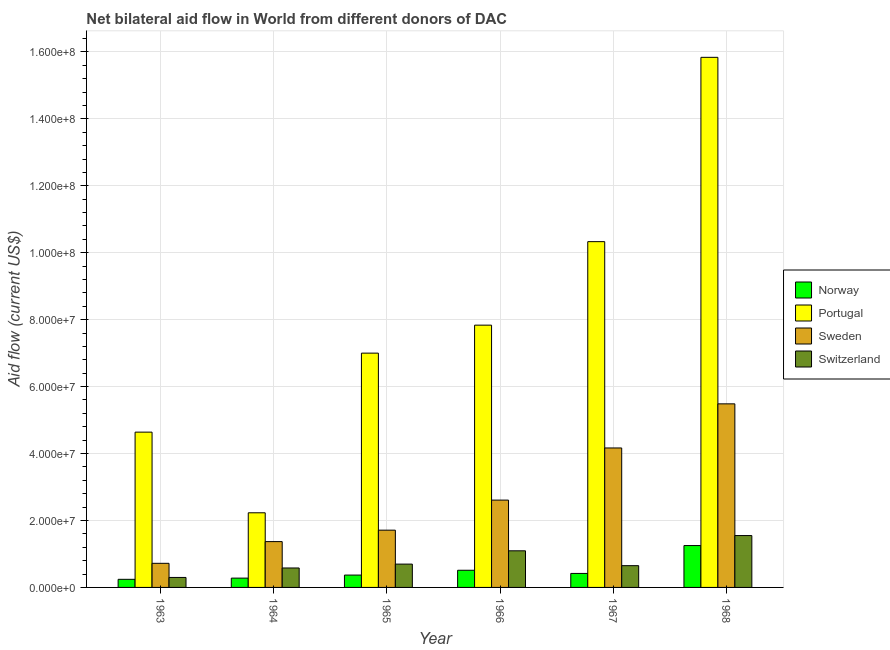How many groups of bars are there?
Your answer should be compact. 6. Are the number of bars per tick equal to the number of legend labels?
Offer a very short reply. Yes. Are the number of bars on each tick of the X-axis equal?
Ensure brevity in your answer.  Yes. How many bars are there on the 6th tick from the right?
Offer a terse response. 4. What is the label of the 6th group of bars from the left?
Make the answer very short. 1968. What is the amount of aid given by norway in 1964?
Make the answer very short. 2.78e+06. Across all years, what is the maximum amount of aid given by sweden?
Provide a short and direct response. 5.48e+07. Across all years, what is the minimum amount of aid given by portugal?
Make the answer very short. 2.23e+07. In which year was the amount of aid given by switzerland maximum?
Ensure brevity in your answer.  1968. In which year was the amount of aid given by sweden minimum?
Make the answer very short. 1963. What is the total amount of aid given by norway in the graph?
Your answer should be very brief. 3.07e+07. What is the difference between the amount of aid given by portugal in 1963 and that in 1966?
Your answer should be very brief. -3.20e+07. What is the difference between the amount of aid given by sweden in 1963 and the amount of aid given by portugal in 1966?
Your answer should be compact. -1.89e+07. What is the average amount of aid given by norway per year?
Your response must be concise. 5.12e+06. In how many years, is the amount of aid given by norway greater than 60000000 US$?
Your response must be concise. 0. What is the ratio of the amount of aid given by sweden in 1965 to that in 1968?
Give a very brief answer. 0.31. Is the amount of aid given by switzerland in 1963 less than that in 1968?
Your answer should be very brief. Yes. What is the difference between the highest and the second highest amount of aid given by switzerland?
Your answer should be very brief. 4.56e+06. What is the difference between the highest and the lowest amount of aid given by switzerland?
Offer a very short reply. 1.25e+07. In how many years, is the amount of aid given by sweden greater than the average amount of aid given by sweden taken over all years?
Your response must be concise. 2. Is the sum of the amount of aid given by portugal in 1965 and 1966 greater than the maximum amount of aid given by norway across all years?
Offer a terse response. No. What does the 4th bar from the right in 1966 represents?
Provide a short and direct response. Norway. Is it the case that in every year, the sum of the amount of aid given by norway and amount of aid given by portugal is greater than the amount of aid given by sweden?
Keep it short and to the point. Yes. How many years are there in the graph?
Provide a short and direct response. 6. What is the difference between two consecutive major ticks on the Y-axis?
Provide a short and direct response. 2.00e+07. Are the values on the major ticks of Y-axis written in scientific E-notation?
Offer a very short reply. Yes. Does the graph contain any zero values?
Offer a terse response. No. How many legend labels are there?
Offer a terse response. 4. How are the legend labels stacked?
Your answer should be very brief. Vertical. What is the title of the graph?
Provide a short and direct response. Net bilateral aid flow in World from different donors of DAC. What is the label or title of the Y-axis?
Make the answer very short. Aid flow (current US$). What is the Aid flow (current US$) of Norway in 1963?
Your answer should be compact. 2.42e+06. What is the Aid flow (current US$) of Portugal in 1963?
Your response must be concise. 4.64e+07. What is the Aid flow (current US$) in Sweden in 1963?
Give a very brief answer. 7.20e+06. What is the Aid flow (current US$) in Switzerland in 1963?
Your answer should be very brief. 2.98e+06. What is the Aid flow (current US$) of Norway in 1964?
Provide a short and direct response. 2.78e+06. What is the Aid flow (current US$) in Portugal in 1964?
Provide a short and direct response. 2.23e+07. What is the Aid flow (current US$) of Sweden in 1964?
Offer a very short reply. 1.37e+07. What is the Aid flow (current US$) in Switzerland in 1964?
Provide a short and direct response. 5.81e+06. What is the Aid flow (current US$) of Norway in 1965?
Give a very brief answer. 3.69e+06. What is the Aid flow (current US$) in Portugal in 1965?
Your answer should be very brief. 7.00e+07. What is the Aid flow (current US$) in Sweden in 1965?
Your response must be concise. 1.71e+07. What is the Aid flow (current US$) in Switzerland in 1965?
Offer a very short reply. 6.97e+06. What is the Aid flow (current US$) in Norway in 1966?
Offer a very short reply. 5.13e+06. What is the Aid flow (current US$) of Portugal in 1966?
Make the answer very short. 7.84e+07. What is the Aid flow (current US$) of Sweden in 1966?
Offer a very short reply. 2.61e+07. What is the Aid flow (current US$) in Switzerland in 1966?
Provide a succinct answer. 1.09e+07. What is the Aid flow (current US$) of Norway in 1967?
Provide a succinct answer. 4.18e+06. What is the Aid flow (current US$) in Portugal in 1967?
Make the answer very short. 1.03e+08. What is the Aid flow (current US$) of Sweden in 1967?
Offer a very short reply. 4.17e+07. What is the Aid flow (current US$) of Switzerland in 1967?
Ensure brevity in your answer.  6.50e+06. What is the Aid flow (current US$) of Norway in 1968?
Your response must be concise. 1.25e+07. What is the Aid flow (current US$) of Portugal in 1968?
Your response must be concise. 1.58e+08. What is the Aid flow (current US$) of Sweden in 1968?
Give a very brief answer. 5.48e+07. What is the Aid flow (current US$) of Switzerland in 1968?
Offer a terse response. 1.55e+07. Across all years, what is the maximum Aid flow (current US$) in Norway?
Make the answer very short. 1.25e+07. Across all years, what is the maximum Aid flow (current US$) in Portugal?
Give a very brief answer. 1.58e+08. Across all years, what is the maximum Aid flow (current US$) of Sweden?
Offer a terse response. 5.48e+07. Across all years, what is the maximum Aid flow (current US$) in Switzerland?
Provide a succinct answer. 1.55e+07. Across all years, what is the minimum Aid flow (current US$) of Norway?
Make the answer very short. 2.42e+06. Across all years, what is the minimum Aid flow (current US$) of Portugal?
Provide a succinct answer. 2.23e+07. Across all years, what is the minimum Aid flow (current US$) in Sweden?
Provide a succinct answer. 7.20e+06. Across all years, what is the minimum Aid flow (current US$) in Switzerland?
Your answer should be very brief. 2.98e+06. What is the total Aid flow (current US$) in Norway in the graph?
Ensure brevity in your answer.  3.07e+07. What is the total Aid flow (current US$) of Portugal in the graph?
Give a very brief answer. 4.79e+08. What is the total Aid flow (current US$) in Sweden in the graph?
Provide a short and direct response. 1.61e+08. What is the total Aid flow (current US$) in Switzerland in the graph?
Give a very brief answer. 4.87e+07. What is the difference between the Aid flow (current US$) of Norway in 1963 and that in 1964?
Offer a very short reply. -3.60e+05. What is the difference between the Aid flow (current US$) of Portugal in 1963 and that in 1964?
Provide a succinct answer. 2.41e+07. What is the difference between the Aid flow (current US$) in Sweden in 1963 and that in 1964?
Ensure brevity in your answer.  -6.49e+06. What is the difference between the Aid flow (current US$) of Switzerland in 1963 and that in 1964?
Provide a short and direct response. -2.83e+06. What is the difference between the Aid flow (current US$) in Norway in 1963 and that in 1965?
Your answer should be very brief. -1.27e+06. What is the difference between the Aid flow (current US$) in Portugal in 1963 and that in 1965?
Provide a succinct answer. -2.36e+07. What is the difference between the Aid flow (current US$) of Sweden in 1963 and that in 1965?
Offer a terse response. -9.91e+06. What is the difference between the Aid flow (current US$) of Switzerland in 1963 and that in 1965?
Your answer should be very brief. -3.99e+06. What is the difference between the Aid flow (current US$) in Norway in 1963 and that in 1966?
Provide a succinct answer. -2.71e+06. What is the difference between the Aid flow (current US$) of Portugal in 1963 and that in 1966?
Provide a succinct answer. -3.20e+07. What is the difference between the Aid flow (current US$) of Sweden in 1963 and that in 1966?
Provide a short and direct response. -1.89e+07. What is the difference between the Aid flow (current US$) in Switzerland in 1963 and that in 1966?
Offer a terse response. -7.96e+06. What is the difference between the Aid flow (current US$) of Norway in 1963 and that in 1967?
Provide a succinct answer. -1.76e+06. What is the difference between the Aid flow (current US$) in Portugal in 1963 and that in 1967?
Offer a very short reply. -5.69e+07. What is the difference between the Aid flow (current US$) of Sweden in 1963 and that in 1967?
Give a very brief answer. -3.45e+07. What is the difference between the Aid flow (current US$) of Switzerland in 1963 and that in 1967?
Your response must be concise. -3.52e+06. What is the difference between the Aid flow (current US$) in Norway in 1963 and that in 1968?
Ensure brevity in your answer.  -1.01e+07. What is the difference between the Aid flow (current US$) in Portugal in 1963 and that in 1968?
Offer a very short reply. -1.12e+08. What is the difference between the Aid flow (current US$) of Sweden in 1963 and that in 1968?
Offer a very short reply. -4.76e+07. What is the difference between the Aid flow (current US$) in Switzerland in 1963 and that in 1968?
Your response must be concise. -1.25e+07. What is the difference between the Aid flow (current US$) of Norway in 1964 and that in 1965?
Provide a succinct answer. -9.10e+05. What is the difference between the Aid flow (current US$) in Portugal in 1964 and that in 1965?
Provide a succinct answer. -4.77e+07. What is the difference between the Aid flow (current US$) of Sweden in 1964 and that in 1965?
Provide a short and direct response. -3.42e+06. What is the difference between the Aid flow (current US$) in Switzerland in 1964 and that in 1965?
Provide a succinct answer. -1.16e+06. What is the difference between the Aid flow (current US$) of Norway in 1964 and that in 1966?
Your answer should be very brief. -2.35e+06. What is the difference between the Aid flow (current US$) in Portugal in 1964 and that in 1966?
Your answer should be very brief. -5.61e+07. What is the difference between the Aid flow (current US$) in Sweden in 1964 and that in 1966?
Offer a terse response. -1.24e+07. What is the difference between the Aid flow (current US$) of Switzerland in 1964 and that in 1966?
Give a very brief answer. -5.13e+06. What is the difference between the Aid flow (current US$) of Norway in 1964 and that in 1967?
Ensure brevity in your answer.  -1.40e+06. What is the difference between the Aid flow (current US$) in Portugal in 1964 and that in 1967?
Ensure brevity in your answer.  -8.10e+07. What is the difference between the Aid flow (current US$) of Sweden in 1964 and that in 1967?
Your answer should be compact. -2.80e+07. What is the difference between the Aid flow (current US$) in Switzerland in 1964 and that in 1967?
Your answer should be compact. -6.90e+05. What is the difference between the Aid flow (current US$) in Norway in 1964 and that in 1968?
Ensure brevity in your answer.  -9.73e+06. What is the difference between the Aid flow (current US$) in Portugal in 1964 and that in 1968?
Provide a short and direct response. -1.36e+08. What is the difference between the Aid flow (current US$) in Sweden in 1964 and that in 1968?
Your response must be concise. -4.12e+07. What is the difference between the Aid flow (current US$) of Switzerland in 1964 and that in 1968?
Ensure brevity in your answer.  -9.69e+06. What is the difference between the Aid flow (current US$) of Norway in 1965 and that in 1966?
Offer a terse response. -1.44e+06. What is the difference between the Aid flow (current US$) of Portugal in 1965 and that in 1966?
Give a very brief answer. -8.36e+06. What is the difference between the Aid flow (current US$) in Sweden in 1965 and that in 1966?
Provide a short and direct response. -8.98e+06. What is the difference between the Aid flow (current US$) of Switzerland in 1965 and that in 1966?
Give a very brief answer. -3.97e+06. What is the difference between the Aid flow (current US$) of Norway in 1965 and that in 1967?
Make the answer very short. -4.90e+05. What is the difference between the Aid flow (current US$) in Portugal in 1965 and that in 1967?
Offer a terse response. -3.33e+07. What is the difference between the Aid flow (current US$) of Sweden in 1965 and that in 1967?
Keep it short and to the point. -2.46e+07. What is the difference between the Aid flow (current US$) of Switzerland in 1965 and that in 1967?
Your answer should be compact. 4.70e+05. What is the difference between the Aid flow (current US$) of Norway in 1965 and that in 1968?
Offer a very short reply. -8.82e+06. What is the difference between the Aid flow (current US$) of Portugal in 1965 and that in 1968?
Offer a terse response. -8.84e+07. What is the difference between the Aid flow (current US$) in Sweden in 1965 and that in 1968?
Keep it short and to the point. -3.77e+07. What is the difference between the Aid flow (current US$) in Switzerland in 1965 and that in 1968?
Make the answer very short. -8.53e+06. What is the difference between the Aid flow (current US$) of Norway in 1966 and that in 1967?
Keep it short and to the point. 9.50e+05. What is the difference between the Aid flow (current US$) in Portugal in 1966 and that in 1967?
Your answer should be compact. -2.50e+07. What is the difference between the Aid flow (current US$) of Sweden in 1966 and that in 1967?
Your answer should be compact. -1.56e+07. What is the difference between the Aid flow (current US$) of Switzerland in 1966 and that in 1967?
Your answer should be compact. 4.44e+06. What is the difference between the Aid flow (current US$) of Norway in 1966 and that in 1968?
Offer a terse response. -7.38e+06. What is the difference between the Aid flow (current US$) in Portugal in 1966 and that in 1968?
Your response must be concise. -8.00e+07. What is the difference between the Aid flow (current US$) in Sweden in 1966 and that in 1968?
Offer a very short reply. -2.88e+07. What is the difference between the Aid flow (current US$) of Switzerland in 1966 and that in 1968?
Your answer should be compact. -4.56e+06. What is the difference between the Aid flow (current US$) of Norway in 1967 and that in 1968?
Your answer should be very brief. -8.33e+06. What is the difference between the Aid flow (current US$) in Portugal in 1967 and that in 1968?
Offer a very short reply. -5.51e+07. What is the difference between the Aid flow (current US$) of Sweden in 1967 and that in 1968?
Give a very brief answer. -1.32e+07. What is the difference between the Aid flow (current US$) in Switzerland in 1967 and that in 1968?
Your response must be concise. -9.00e+06. What is the difference between the Aid flow (current US$) of Norway in 1963 and the Aid flow (current US$) of Portugal in 1964?
Provide a short and direct response. -1.99e+07. What is the difference between the Aid flow (current US$) in Norway in 1963 and the Aid flow (current US$) in Sweden in 1964?
Provide a succinct answer. -1.13e+07. What is the difference between the Aid flow (current US$) of Norway in 1963 and the Aid flow (current US$) of Switzerland in 1964?
Your answer should be compact. -3.39e+06. What is the difference between the Aid flow (current US$) in Portugal in 1963 and the Aid flow (current US$) in Sweden in 1964?
Offer a terse response. 3.27e+07. What is the difference between the Aid flow (current US$) of Portugal in 1963 and the Aid flow (current US$) of Switzerland in 1964?
Your answer should be very brief. 4.06e+07. What is the difference between the Aid flow (current US$) in Sweden in 1963 and the Aid flow (current US$) in Switzerland in 1964?
Keep it short and to the point. 1.39e+06. What is the difference between the Aid flow (current US$) in Norway in 1963 and the Aid flow (current US$) in Portugal in 1965?
Ensure brevity in your answer.  -6.76e+07. What is the difference between the Aid flow (current US$) of Norway in 1963 and the Aid flow (current US$) of Sweden in 1965?
Your response must be concise. -1.47e+07. What is the difference between the Aid flow (current US$) in Norway in 1963 and the Aid flow (current US$) in Switzerland in 1965?
Provide a succinct answer. -4.55e+06. What is the difference between the Aid flow (current US$) of Portugal in 1963 and the Aid flow (current US$) of Sweden in 1965?
Offer a terse response. 2.93e+07. What is the difference between the Aid flow (current US$) in Portugal in 1963 and the Aid flow (current US$) in Switzerland in 1965?
Your response must be concise. 3.94e+07. What is the difference between the Aid flow (current US$) of Sweden in 1963 and the Aid flow (current US$) of Switzerland in 1965?
Ensure brevity in your answer.  2.30e+05. What is the difference between the Aid flow (current US$) of Norway in 1963 and the Aid flow (current US$) of Portugal in 1966?
Give a very brief answer. -7.59e+07. What is the difference between the Aid flow (current US$) in Norway in 1963 and the Aid flow (current US$) in Sweden in 1966?
Keep it short and to the point. -2.37e+07. What is the difference between the Aid flow (current US$) in Norway in 1963 and the Aid flow (current US$) in Switzerland in 1966?
Keep it short and to the point. -8.52e+06. What is the difference between the Aid flow (current US$) of Portugal in 1963 and the Aid flow (current US$) of Sweden in 1966?
Your answer should be very brief. 2.03e+07. What is the difference between the Aid flow (current US$) of Portugal in 1963 and the Aid flow (current US$) of Switzerland in 1966?
Your response must be concise. 3.55e+07. What is the difference between the Aid flow (current US$) in Sweden in 1963 and the Aid flow (current US$) in Switzerland in 1966?
Make the answer very short. -3.74e+06. What is the difference between the Aid flow (current US$) of Norway in 1963 and the Aid flow (current US$) of Portugal in 1967?
Provide a short and direct response. -1.01e+08. What is the difference between the Aid flow (current US$) in Norway in 1963 and the Aid flow (current US$) in Sweden in 1967?
Offer a terse response. -3.92e+07. What is the difference between the Aid flow (current US$) in Norway in 1963 and the Aid flow (current US$) in Switzerland in 1967?
Keep it short and to the point. -4.08e+06. What is the difference between the Aid flow (current US$) of Portugal in 1963 and the Aid flow (current US$) of Sweden in 1967?
Provide a succinct answer. 4.73e+06. What is the difference between the Aid flow (current US$) in Portugal in 1963 and the Aid flow (current US$) in Switzerland in 1967?
Offer a terse response. 3.99e+07. What is the difference between the Aid flow (current US$) in Sweden in 1963 and the Aid flow (current US$) in Switzerland in 1967?
Your answer should be compact. 7.00e+05. What is the difference between the Aid flow (current US$) of Norway in 1963 and the Aid flow (current US$) of Portugal in 1968?
Keep it short and to the point. -1.56e+08. What is the difference between the Aid flow (current US$) in Norway in 1963 and the Aid flow (current US$) in Sweden in 1968?
Offer a very short reply. -5.24e+07. What is the difference between the Aid flow (current US$) of Norway in 1963 and the Aid flow (current US$) of Switzerland in 1968?
Provide a succinct answer. -1.31e+07. What is the difference between the Aid flow (current US$) of Portugal in 1963 and the Aid flow (current US$) of Sweden in 1968?
Provide a short and direct response. -8.45e+06. What is the difference between the Aid flow (current US$) of Portugal in 1963 and the Aid flow (current US$) of Switzerland in 1968?
Offer a terse response. 3.09e+07. What is the difference between the Aid flow (current US$) in Sweden in 1963 and the Aid flow (current US$) in Switzerland in 1968?
Ensure brevity in your answer.  -8.30e+06. What is the difference between the Aid flow (current US$) in Norway in 1964 and the Aid flow (current US$) in Portugal in 1965?
Keep it short and to the point. -6.72e+07. What is the difference between the Aid flow (current US$) of Norway in 1964 and the Aid flow (current US$) of Sweden in 1965?
Keep it short and to the point. -1.43e+07. What is the difference between the Aid flow (current US$) in Norway in 1964 and the Aid flow (current US$) in Switzerland in 1965?
Offer a terse response. -4.19e+06. What is the difference between the Aid flow (current US$) of Portugal in 1964 and the Aid flow (current US$) of Sweden in 1965?
Make the answer very short. 5.19e+06. What is the difference between the Aid flow (current US$) of Portugal in 1964 and the Aid flow (current US$) of Switzerland in 1965?
Make the answer very short. 1.53e+07. What is the difference between the Aid flow (current US$) in Sweden in 1964 and the Aid flow (current US$) in Switzerland in 1965?
Your answer should be very brief. 6.72e+06. What is the difference between the Aid flow (current US$) of Norway in 1964 and the Aid flow (current US$) of Portugal in 1966?
Offer a terse response. -7.56e+07. What is the difference between the Aid flow (current US$) in Norway in 1964 and the Aid flow (current US$) in Sweden in 1966?
Offer a terse response. -2.33e+07. What is the difference between the Aid flow (current US$) of Norway in 1964 and the Aid flow (current US$) of Switzerland in 1966?
Offer a terse response. -8.16e+06. What is the difference between the Aid flow (current US$) in Portugal in 1964 and the Aid flow (current US$) in Sweden in 1966?
Offer a very short reply. -3.79e+06. What is the difference between the Aid flow (current US$) in Portugal in 1964 and the Aid flow (current US$) in Switzerland in 1966?
Offer a terse response. 1.14e+07. What is the difference between the Aid flow (current US$) in Sweden in 1964 and the Aid flow (current US$) in Switzerland in 1966?
Offer a very short reply. 2.75e+06. What is the difference between the Aid flow (current US$) in Norway in 1964 and the Aid flow (current US$) in Portugal in 1967?
Provide a short and direct response. -1.01e+08. What is the difference between the Aid flow (current US$) of Norway in 1964 and the Aid flow (current US$) of Sweden in 1967?
Your answer should be compact. -3.89e+07. What is the difference between the Aid flow (current US$) of Norway in 1964 and the Aid flow (current US$) of Switzerland in 1967?
Keep it short and to the point. -3.72e+06. What is the difference between the Aid flow (current US$) in Portugal in 1964 and the Aid flow (current US$) in Sweden in 1967?
Your answer should be compact. -1.94e+07. What is the difference between the Aid flow (current US$) of Portugal in 1964 and the Aid flow (current US$) of Switzerland in 1967?
Make the answer very short. 1.58e+07. What is the difference between the Aid flow (current US$) in Sweden in 1964 and the Aid flow (current US$) in Switzerland in 1967?
Your answer should be very brief. 7.19e+06. What is the difference between the Aid flow (current US$) of Norway in 1964 and the Aid flow (current US$) of Portugal in 1968?
Provide a succinct answer. -1.56e+08. What is the difference between the Aid flow (current US$) in Norway in 1964 and the Aid flow (current US$) in Sweden in 1968?
Offer a very short reply. -5.21e+07. What is the difference between the Aid flow (current US$) of Norway in 1964 and the Aid flow (current US$) of Switzerland in 1968?
Provide a short and direct response. -1.27e+07. What is the difference between the Aid flow (current US$) of Portugal in 1964 and the Aid flow (current US$) of Sweden in 1968?
Offer a terse response. -3.26e+07. What is the difference between the Aid flow (current US$) in Portugal in 1964 and the Aid flow (current US$) in Switzerland in 1968?
Your answer should be compact. 6.80e+06. What is the difference between the Aid flow (current US$) in Sweden in 1964 and the Aid flow (current US$) in Switzerland in 1968?
Make the answer very short. -1.81e+06. What is the difference between the Aid flow (current US$) in Norway in 1965 and the Aid flow (current US$) in Portugal in 1966?
Your answer should be compact. -7.47e+07. What is the difference between the Aid flow (current US$) in Norway in 1965 and the Aid flow (current US$) in Sweden in 1966?
Provide a succinct answer. -2.24e+07. What is the difference between the Aid flow (current US$) of Norway in 1965 and the Aid flow (current US$) of Switzerland in 1966?
Ensure brevity in your answer.  -7.25e+06. What is the difference between the Aid flow (current US$) in Portugal in 1965 and the Aid flow (current US$) in Sweden in 1966?
Your response must be concise. 4.39e+07. What is the difference between the Aid flow (current US$) of Portugal in 1965 and the Aid flow (current US$) of Switzerland in 1966?
Provide a succinct answer. 5.91e+07. What is the difference between the Aid flow (current US$) in Sweden in 1965 and the Aid flow (current US$) in Switzerland in 1966?
Keep it short and to the point. 6.17e+06. What is the difference between the Aid flow (current US$) in Norway in 1965 and the Aid flow (current US$) in Portugal in 1967?
Your answer should be compact. -9.96e+07. What is the difference between the Aid flow (current US$) of Norway in 1965 and the Aid flow (current US$) of Sweden in 1967?
Keep it short and to the point. -3.80e+07. What is the difference between the Aid flow (current US$) of Norway in 1965 and the Aid flow (current US$) of Switzerland in 1967?
Keep it short and to the point. -2.81e+06. What is the difference between the Aid flow (current US$) in Portugal in 1965 and the Aid flow (current US$) in Sweden in 1967?
Make the answer very short. 2.83e+07. What is the difference between the Aid flow (current US$) of Portugal in 1965 and the Aid flow (current US$) of Switzerland in 1967?
Offer a very short reply. 6.35e+07. What is the difference between the Aid flow (current US$) in Sweden in 1965 and the Aid flow (current US$) in Switzerland in 1967?
Provide a short and direct response. 1.06e+07. What is the difference between the Aid flow (current US$) in Norway in 1965 and the Aid flow (current US$) in Portugal in 1968?
Your answer should be very brief. -1.55e+08. What is the difference between the Aid flow (current US$) in Norway in 1965 and the Aid flow (current US$) in Sweden in 1968?
Ensure brevity in your answer.  -5.12e+07. What is the difference between the Aid flow (current US$) of Norway in 1965 and the Aid flow (current US$) of Switzerland in 1968?
Make the answer very short. -1.18e+07. What is the difference between the Aid flow (current US$) in Portugal in 1965 and the Aid flow (current US$) in Sweden in 1968?
Make the answer very short. 1.52e+07. What is the difference between the Aid flow (current US$) of Portugal in 1965 and the Aid flow (current US$) of Switzerland in 1968?
Offer a very short reply. 5.45e+07. What is the difference between the Aid flow (current US$) of Sweden in 1965 and the Aid flow (current US$) of Switzerland in 1968?
Your answer should be very brief. 1.61e+06. What is the difference between the Aid flow (current US$) of Norway in 1966 and the Aid flow (current US$) of Portugal in 1967?
Provide a succinct answer. -9.82e+07. What is the difference between the Aid flow (current US$) of Norway in 1966 and the Aid flow (current US$) of Sweden in 1967?
Offer a very short reply. -3.65e+07. What is the difference between the Aid flow (current US$) in Norway in 1966 and the Aid flow (current US$) in Switzerland in 1967?
Offer a terse response. -1.37e+06. What is the difference between the Aid flow (current US$) in Portugal in 1966 and the Aid flow (current US$) in Sweden in 1967?
Make the answer very short. 3.67e+07. What is the difference between the Aid flow (current US$) of Portugal in 1966 and the Aid flow (current US$) of Switzerland in 1967?
Keep it short and to the point. 7.19e+07. What is the difference between the Aid flow (current US$) of Sweden in 1966 and the Aid flow (current US$) of Switzerland in 1967?
Ensure brevity in your answer.  1.96e+07. What is the difference between the Aid flow (current US$) of Norway in 1966 and the Aid flow (current US$) of Portugal in 1968?
Your response must be concise. -1.53e+08. What is the difference between the Aid flow (current US$) in Norway in 1966 and the Aid flow (current US$) in Sweden in 1968?
Make the answer very short. -4.97e+07. What is the difference between the Aid flow (current US$) of Norway in 1966 and the Aid flow (current US$) of Switzerland in 1968?
Your answer should be compact. -1.04e+07. What is the difference between the Aid flow (current US$) of Portugal in 1966 and the Aid flow (current US$) of Sweden in 1968?
Your answer should be compact. 2.35e+07. What is the difference between the Aid flow (current US$) of Portugal in 1966 and the Aid flow (current US$) of Switzerland in 1968?
Make the answer very short. 6.29e+07. What is the difference between the Aid flow (current US$) in Sweden in 1966 and the Aid flow (current US$) in Switzerland in 1968?
Ensure brevity in your answer.  1.06e+07. What is the difference between the Aid flow (current US$) of Norway in 1967 and the Aid flow (current US$) of Portugal in 1968?
Your answer should be very brief. -1.54e+08. What is the difference between the Aid flow (current US$) of Norway in 1967 and the Aid flow (current US$) of Sweden in 1968?
Offer a terse response. -5.07e+07. What is the difference between the Aid flow (current US$) in Norway in 1967 and the Aid flow (current US$) in Switzerland in 1968?
Your response must be concise. -1.13e+07. What is the difference between the Aid flow (current US$) in Portugal in 1967 and the Aid flow (current US$) in Sweden in 1968?
Provide a short and direct response. 4.85e+07. What is the difference between the Aid flow (current US$) in Portugal in 1967 and the Aid flow (current US$) in Switzerland in 1968?
Your answer should be compact. 8.78e+07. What is the difference between the Aid flow (current US$) in Sweden in 1967 and the Aid flow (current US$) in Switzerland in 1968?
Offer a terse response. 2.62e+07. What is the average Aid flow (current US$) of Norway per year?
Your answer should be compact. 5.12e+06. What is the average Aid flow (current US$) in Portugal per year?
Your response must be concise. 7.98e+07. What is the average Aid flow (current US$) in Sweden per year?
Your response must be concise. 2.68e+07. What is the average Aid flow (current US$) of Switzerland per year?
Offer a very short reply. 8.12e+06. In the year 1963, what is the difference between the Aid flow (current US$) in Norway and Aid flow (current US$) in Portugal?
Provide a short and direct response. -4.40e+07. In the year 1963, what is the difference between the Aid flow (current US$) of Norway and Aid flow (current US$) of Sweden?
Your answer should be very brief. -4.78e+06. In the year 1963, what is the difference between the Aid flow (current US$) of Norway and Aid flow (current US$) of Switzerland?
Offer a very short reply. -5.60e+05. In the year 1963, what is the difference between the Aid flow (current US$) of Portugal and Aid flow (current US$) of Sweden?
Your response must be concise. 3.92e+07. In the year 1963, what is the difference between the Aid flow (current US$) of Portugal and Aid flow (current US$) of Switzerland?
Offer a terse response. 4.34e+07. In the year 1963, what is the difference between the Aid flow (current US$) in Sweden and Aid flow (current US$) in Switzerland?
Ensure brevity in your answer.  4.22e+06. In the year 1964, what is the difference between the Aid flow (current US$) in Norway and Aid flow (current US$) in Portugal?
Give a very brief answer. -1.95e+07. In the year 1964, what is the difference between the Aid flow (current US$) in Norway and Aid flow (current US$) in Sweden?
Your answer should be very brief. -1.09e+07. In the year 1964, what is the difference between the Aid flow (current US$) in Norway and Aid flow (current US$) in Switzerland?
Provide a short and direct response. -3.03e+06. In the year 1964, what is the difference between the Aid flow (current US$) of Portugal and Aid flow (current US$) of Sweden?
Keep it short and to the point. 8.61e+06. In the year 1964, what is the difference between the Aid flow (current US$) of Portugal and Aid flow (current US$) of Switzerland?
Keep it short and to the point. 1.65e+07. In the year 1964, what is the difference between the Aid flow (current US$) in Sweden and Aid flow (current US$) in Switzerland?
Ensure brevity in your answer.  7.88e+06. In the year 1965, what is the difference between the Aid flow (current US$) in Norway and Aid flow (current US$) in Portugal?
Ensure brevity in your answer.  -6.63e+07. In the year 1965, what is the difference between the Aid flow (current US$) of Norway and Aid flow (current US$) of Sweden?
Keep it short and to the point. -1.34e+07. In the year 1965, what is the difference between the Aid flow (current US$) of Norway and Aid flow (current US$) of Switzerland?
Make the answer very short. -3.28e+06. In the year 1965, what is the difference between the Aid flow (current US$) in Portugal and Aid flow (current US$) in Sweden?
Provide a short and direct response. 5.29e+07. In the year 1965, what is the difference between the Aid flow (current US$) of Portugal and Aid flow (current US$) of Switzerland?
Offer a very short reply. 6.30e+07. In the year 1965, what is the difference between the Aid flow (current US$) in Sweden and Aid flow (current US$) in Switzerland?
Provide a short and direct response. 1.01e+07. In the year 1966, what is the difference between the Aid flow (current US$) of Norway and Aid flow (current US$) of Portugal?
Your answer should be compact. -7.32e+07. In the year 1966, what is the difference between the Aid flow (current US$) in Norway and Aid flow (current US$) in Sweden?
Make the answer very short. -2.10e+07. In the year 1966, what is the difference between the Aid flow (current US$) in Norway and Aid flow (current US$) in Switzerland?
Offer a very short reply. -5.81e+06. In the year 1966, what is the difference between the Aid flow (current US$) of Portugal and Aid flow (current US$) of Sweden?
Make the answer very short. 5.23e+07. In the year 1966, what is the difference between the Aid flow (current US$) in Portugal and Aid flow (current US$) in Switzerland?
Offer a terse response. 6.74e+07. In the year 1966, what is the difference between the Aid flow (current US$) in Sweden and Aid flow (current US$) in Switzerland?
Your answer should be compact. 1.52e+07. In the year 1967, what is the difference between the Aid flow (current US$) of Norway and Aid flow (current US$) of Portugal?
Your answer should be very brief. -9.91e+07. In the year 1967, what is the difference between the Aid flow (current US$) in Norway and Aid flow (current US$) in Sweden?
Offer a terse response. -3.75e+07. In the year 1967, what is the difference between the Aid flow (current US$) of Norway and Aid flow (current US$) of Switzerland?
Provide a short and direct response. -2.32e+06. In the year 1967, what is the difference between the Aid flow (current US$) in Portugal and Aid flow (current US$) in Sweden?
Make the answer very short. 6.16e+07. In the year 1967, what is the difference between the Aid flow (current US$) of Portugal and Aid flow (current US$) of Switzerland?
Give a very brief answer. 9.68e+07. In the year 1967, what is the difference between the Aid flow (current US$) in Sweden and Aid flow (current US$) in Switzerland?
Your answer should be very brief. 3.52e+07. In the year 1968, what is the difference between the Aid flow (current US$) in Norway and Aid flow (current US$) in Portugal?
Offer a very short reply. -1.46e+08. In the year 1968, what is the difference between the Aid flow (current US$) in Norway and Aid flow (current US$) in Sweden?
Your answer should be compact. -4.23e+07. In the year 1968, what is the difference between the Aid flow (current US$) in Norway and Aid flow (current US$) in Switzerland?
Offer a very short reply. -2.99e+06. In the year 1968, what is the difference between the Aid flow (current US$) in Portugal and Aid flow (current US$) in Sweden?
Your answer should be very brief. 1.04e+08. In the year 1968, what is the difference between the Aid flow (current US$) in Portugal and Aid flow (current US$) in Switzerland?
Make the answer very short. 1.43e+08. In the year 1968, what is the difference between the Aid flow (current US$) in Sweden and Aid flow (current US$) in Switzerland?
Provide a short and direct response. 3.94e+07. What is the ratio of the Aid flow (current US$) of Norway in 1963 to that in 1964?
Offer a terse response. 0.87. What is the ratio of the Aid flow (current US$) of Portugal in 1963 to that in 1964?
Your answer should be very brief. 2.08. What is the ratio of the Aid flow (current US$) in Sweden in 1963 to that in 1964?
Your answer should be very brief. 0.53. What is the ratio of the Aid flow (current US$) in Switzerland in 1963 to that in 1964?
Ensure brevity in your answer.  0.51. What is the ratio of the Aid flow (current US$) of Norway in 1963 to that in 1965?
Provide a short and direct response. 0.66. What is the ratio of the Aid flow (current US$) in Portugal in 1963 to that in 1965?
Give a very brief answer. 0.66. What is the ratio of the Aid flow (current US$) of Sweden in 1963 to that in 1965?
Your response must be concise. 0.42. What is the ratio of the Aid flow (current US$) of Switzerland in 1963 to that in 1965?
Offer a very short reply. 0.43. What is the ratio of the Aid flow (current US$) in Norway in 1963 to that in 1966?
Offer a terse response. 0.47. What is the ratio of the Aid flow (current US$) of Portugal in 1963 to that in 1966?
Provide a succinct answer. 0.59. What is the ratio of the Aid flow (current US$) of Sweden in 1963 to that in 1966?
Make the answer very short. 0.28. What is the ratio of the Aid flow (current US$) in Switzerland in 1963 to that in 1966?
Provide a short and direct response. 0.27. What is the ratio of the Aid flow (current US$) of Norway in 1963 to that in 1967?
Your answer should be compact. 0.58. What is the ratio of the Aid flow (current US$) in Portugal in 1963 to that in 1967?
Offer a very short reply. 0.45. What is the ratio of the Aid flow (current US$) of Sweden in 1963 to that in 1967?
Give a very brief answer. 0.17. What is the ratio of the Aid flow (current US$) of Switzerland in 1963 to that in 1967?
Offer a very short reply. 0.46. What is the ratio of the Aid flow (current US$) of Norway in 1963 to that in 1968?
Provide a short and direct response. 0.19. What is the ratio of the Aid flow (current US$) in Portugal in 1963 to that in 1968?
Offer a very short reply. 0.29. What is the ratio of the Aid flow (current US$) in Sweden in 1963 to that in 1968?
Provide a short and direct response. 0.13. What is the ratio of the Aid flow (current US$) in Switzerland in 1963 to that in 1968?
Make the answer very short. 0.19. What is the ratio of the Aid flow (current US$) of Norway in 1964 to that in 1965?
Keep it short and to the point. 0.75. What is the ratio of the Aid flow (current US$) of Portugal in 1964 to that in 1965?
Ensure brevity in your answer.  0.32. What is the ratio of the Aid flow (current US$) of Sweden in 1964 to that in 1965?
Your response must be concise. 0.8. What is the ratio of the Aid flow (current US$) in Switzerland in 1964 to that in 1965?
Give a very brief answer. 0.83. What is the ratio of the Aid flow (current US$) in Norway in 1964 to that in 1966?
Give a very brief answer. 0.54. What is the ratio of the Aid flow (current US$) of Portugal in 1964 to that in 1966?
Ensure brevity in your answer.  0.28. What is the ratio of the Aid flow (current US$) of Sweden in 1964 to that in 1966?
Offer a very short reply. 0.52. What is the ratio of the Aid flow (current US$) of Switzerland in 1964 to that in 1966?
Offer a very short reply. 0.53. What is the ratio of the Aid flow (current US$) in Norway in 1964 to that in 1967?
Provide a succinct answer. 0.67. What is the ratio of the Aid flow (current US$) of Portugal in 1964 to that in 1967?
Offer a very short reply. 0.22. What is the ratio of the Aid flow (current US$) of Sweden in 1964 to that in 1967?
Offer a terse response. 0.33. What is the ratio of the Aid flow (current US$) of Switzerland in 1964 to that in 1967?
Offer a very short reply. 0.89. What is the ratio of the Aid flow (current US$) in Norway in 1964 to that in 1968?
Provide a short and direct response. 0.22. What is the ratio of the Aid flow (current US$) in Portugal in 1964 to that in 1968?
Give a very brief answer. 0.14. What is the ratio of the Aid flow (current US$) in Sweden in 1964 to that in 1968?
Give a very brief answer. 0.25. What is the ratio of the Aid flow (current US$) in Switzerland in 1964 to that in 1968?
Provide a short and direct response. 0.37. What is the ratio of the Aid flow (current US$) of Norway in 1965 to that in 1966?
Make the answer very short. 0.72. What is the ratio of the Aid flow (current US$) of Portugal in 1965 to that in 1966?
Give a very brief answer. 0.89. What is the ratio of the Aid flow (current US$) in Sweden in 1965 to that in 1966?
Ensure brevity in your answer.  0.66. What is the ratio of the Aid flow (current US$) in Switzerland in 1965 to that in 1966?
Your response must be concise. 0.64. What is the ratio of the Aid flow (current US$) in Norway in 1965 to that in 1967?
Keep it short and to the point. 0.88. What is the ratio of the Aid flow (current US$) of Portugal in 1965 to that in 1967?
Provide a succinct answer. 0.68. What is the ratio of the Aid flow (current US$) of Sweden in 1965 to that in 1967?
Ensure brevity in your answer.  0.41. What is the ratio of the Aid flow (current US$) of Switzerland in 1965 to that in 1967?
Offer a terse response. 1.07. What is the ratio of the Aid flow (current US$) in Norway in 1965 to that in 1968?
Ensure brevity in your answer.  0.29. What is the ratio of the Aid flow (current US$) of Portugal in 1965 to that in 1968?
Keep it short and to the point. 0.44. What is the ratio of the Aid flow (current US$) in Sweden in 1965 to that in 1968?
Your answer should be compact. 0.31. What is the ratio of the Aid flow (current US$) of Switzerland in 1965 to that in 1968?
Your answer should be compact. 0.45. What is the ratio of the Aid flow (current US$) in Norway in 1966 to that in 1967?
Give a very brief answer. 1.23. What is the ratio of the Aid flow (current US$) of Portugal in 1966 to that in 1967?
Give a very brief answer. 0.76. What is the ratio of the Aid flow (current US$) of Sweden in 1966 to that in 1967?
Offer a terse response. 0.63. What is the ratio of the Aid flow (current US$) of Switzerland in 1966 to that in 1967?
Make the answer very short. 1.68. What is the ratio of the Aid flow (current US$) of Norway in 1966 to that in 1968?
Offer a very short reply. 0.41. What is the ratio of the Aid flow (current US$) in Portugal in 1966 to that in 1968?
Offer a very short reply. 0.49. What is the ratio of the Aid flow (current US$) of Sweden in 1966 to that in 1968?
Ensure brevity in your answer.  0.48. What is the ratio of the Aid flow (current US$) of Switzerland in 1966 to that in 1968?
Provide a short and direct response. 0.71. What is the ratio of the Aid flow (current US$) in Norway in 1967 to that in 1968?
Provide a short and direct response. 0.33. What is the ratio of the Aid flow (current US$) of Portugal in 1967 to that in 1968?
Offer a very short reply. 0.65. What is the ratio of the Aid flow (current US$) in Sweden in 1967 to that in 1968?
Offer a terse response. 0.76. What is the ratio of the Aid flow (current US$) in Switzerland in 1967 to that in 1968?
Make the answer very short. 0.42. What is the difference between the highest and the second highest Aid flow (current US$) of Norway?
Your response must be concise. 7.38e+06. What is the difference between the highest and the second highest Aid flow (current US$) in Portugal?
Keep it short and to the point. 5.51e+07. What is the difference between the highest and the second highest Aid flow (current US$) in Sweden?
Offer a terse response. 1.32e+07. What is the difference between the highest and the second highest Aid flow (current US$) in Switzerland?
Provide a succinct answer. 4.56e+06. What is the difference between the highest and the lowest Aid flow (current US$) in Norway?
Your answer should be very brief. 1.01e+07. What is the difference between the highest and the lowest Aid flow (current US$) of Portugal?
Provide a succinct answer. 1.36e+08. What is the difference between the highest and the lowest Aid flow (current US$) in Sweden?
Offer a terse response. 4.76e+07. What is the difference between the highest and the lowest Aid flow (current US$) in Switzerland?
Provide a succinct answer. 1.25e+07. 